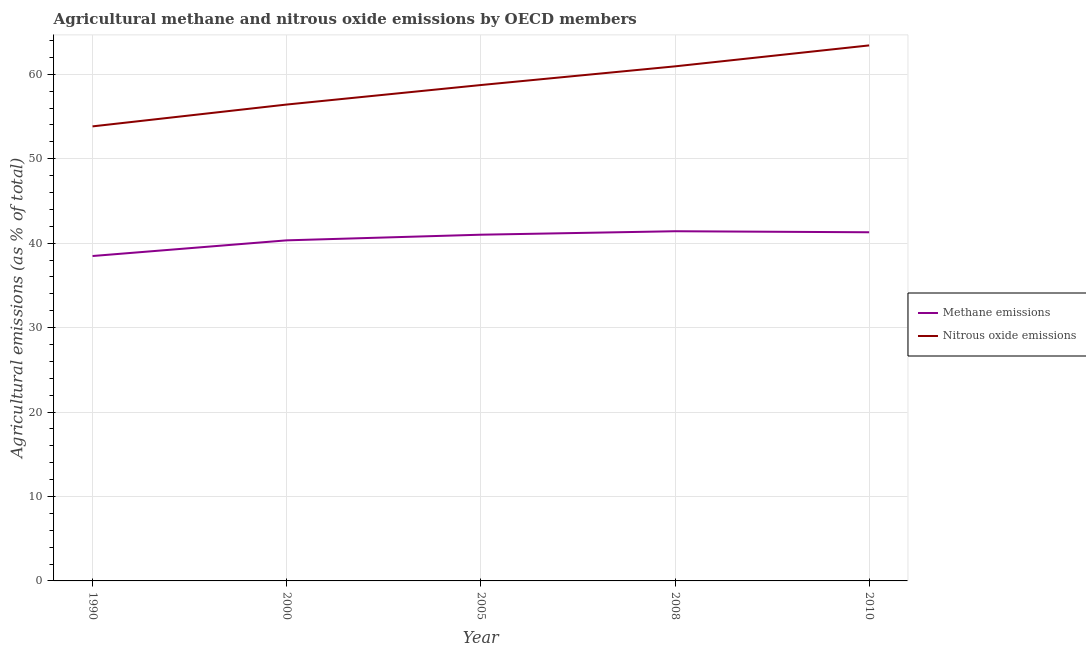How many different coloured lines are there?
Your answer should be compact. 2. Does the line corresponding to amount of nitrous oxide emissions intersect with the line corresponding to amount of methane emissions?
Provide a succinct answer. No. Is the number of lines equal to the number of legend labels?
Provide a short and direct response. Yes. What is the amount of methane emissions in 2010?
Offer a very short reply. 41.29. Across all years, what is the maximum amount of nitrous oxide emissions?
Your response must be concise. 63.42. Across all years, what is the minimum amount of methane emissions?
Your answer should be very brief. 38.48. In which year was the amount of methane emissions maximum?
Give a very brief answer. 2008. What is the total amount of methane emissions in the graph?
Offer a very short reply. 202.52. What is the difference between the amount of nitrous oxide emissions in 2000 and that in 2010?
Your answer should be compact. -7. What is the difference between the amount of methane emissions in 2005 and the amount of nitrous oxide emissions in 2010?
Offer a terse response. -22.42. What is the average amount of nitrous oxide emissions per year?
Make the answer very short. 58.67. In the year 2005, what is the difference between the amount of methane emissions and amount of nitrous oxide emissions?
Ensure brevity in your answer.  -17.72. In how many years, is the amount of nitrous oxide emissions greater than 44 %?
Offer a very short reply. 5. What is the ratio of the amount of nitrous oxide emissions in 1990 to that in 2008?
Offer a terse response. 0.88. Is the amount of methane emissions in 2000 less than that in 2010?
Your answer should be compact. Yes. What is the difference between the highest and the second highest amount of nitrous oxide emissions?
Ensure brevity in your answer.  2.48. What is the difference between the highest and the lowest amount of methane emissions?
Make the answer very short. 2.93. In how many years, is the amount of nitrous oxide emissions greater than the average amount of nitrous oxide emissions taken over all years?
Make the answer very short. 3. Is the sum of the amount of methane emissions in 2008 and 2010 greater than the maximum amount of nitrous oxide emissions across all years?
Your answer should be very brief. Yes. How many lines are there?
Ensure brevity in your answer.  2. How many years are there in the graph?
Make the answer very short. 5. Are the values on the major ticks of Y-axis written in scientific E-notation?
Your answer should be very brief. No. Does the graph contain any zero values?
Give a very brief answer. No. Does the graph contain grids?
Provide a short and direct response. Yes. Where does the legend appear in the graph?
Provide a succinct answer. Center right. How many legend labels are there?
Give a very brief answer. 2. What is the title of the graph?
Your answer should be very brief. Agricultural methane and nitrous oxide emissions by OECD members. Does "2012 US$" appear as one of the legend labels in the graph?
Ensure brevity in your answer.  No. What is the label or title of the Y-axis?
Your answer should be compact. Agricultural emissions (as % of total). What is the Agricultural emissions (as % of total) in Methane emissions in 1990?
Your response must be concise. 38.48. What is the Agricultural emissions (as % of total) in Nitrous oxide emissions in 1990?
Offer a terse response. 53.83. What is the Agricultural emissions (as % of total) in Methane emissions in 2000?
Provide a short and direct response. 40.33. What is the Agricultural emissions (as % of total) of Nitrous oxide emissions in 2000?
Make the answer very short. 56.42. What is the Agricultural emissions (as % of total) in Methane emissions in 2005?
Your response must be concise. 41. What is the Agricultural emissions (as % of total) of Nitrous oxide emissions in 2005?
Offer a terse response. 58.73. What is the Agricultural emissions (as % of total) in Methane emissions in 2008?
Keep it short and to the point. 41.41. What is the Agricultural emissions (as % of total) of Nitrous oxide emissions in 2008?
Offer a very short reply. 60.94. What is the Agricultural emissions (as % of total) of Methane emissions in 2010?
Provide a short and direct response. 41.29. What is the Agricultural emissions (as % of total) in Nitrous oxide emissions in 2010?
Give a very brief answer. 63.42. Across all years, what is the maximum Agricultural emissions (as % of total) of Methane emissions?
Keep it short and to the point. 41.41. Across all years, what is the maximum Agricultural emissions (as % of total) in Nitrous oxide emissions?
Give a very brief answer. 63.42. Across all years, what is the minimum Agricultural emissions (as % of total) of Methane emissions?
Your response must be concise. 38.48. Across all years, what is the minimum Agricultural emissions (as % of total) in Nitrous oxide emissions?
Ensure brevity in your answer.  53.83. What is the total Agricultural emissions (as % of total) in Methane emissions in the graph?
Provide a succinct answer. 202.52. What is the total Agricultural emissions (as % of total) of Nitrous oxide emissions in the graph?
Offer a very short reply. 293.34. What is the difference between the Agricultural emissions (as % of total) in Methane emissions in 1990 and that in 2000?
Your response must be concise. -1.86. What is the difference between the Agricultural emissions (as % of total) of Nitrous oxide emissions in 1990 and that in 2000?
Ensure brevity in your answer.  -2.59. What is the difference between the Agricultural emissions (as % of total) in Methane emissions in 1990 and that in 2005?
Your response must be concise. -2.52. What is the difference between the Agricultural emissions (as % of total) in Nitrous oxide emissions in 1990 and that in 2005?
Your answer should be very brief. -4.9. What is the difference between the Agricultural emissions (as % of total) in Methane emissions in 1990 and that in 2008?
Your response must be concise. -2.93. What is the difference between the Agricultural emissions (as % of total) in Nitrous oxide emissions in 1990 and that in 2008?
Keep it short and to the point. -7.11. What is the difference between the Agricultural emissions (as % of total) of Methane emissions in 1990 and that in 2010?
Provide a succinct answer. -2.81. What is the difference between the Agricultural emissions (as % of total) in Nitrous oxide emissions in 1990 and that in 2010?
Make the answer very short. -9.59. What is the difference between the Agricultural emissions (as % of total) of Methane emissions in 2000 and that in 2005?
Make the answer very short. -0.67. What is the difference between the Agricultural emissions (as % of total) in Nitrous oxide emissions in 2000 and that in 2005?
Offer a very short reply. -2.31. What is the difference between the Agricultural emissions (as % of total) of Methane emissions in 2000 and that in 2008?
Make the answer very short. -1.08. What is the difference between the Agricultural emissions (as % of total) in Nitrous oxide emissions in 2000 and that in 2008?
Your answer should be very brief. -4.52. What is the difference between the Agricultural emissions (as % of total) in Methane emissions in 2000 and that in 2010?
Give a very brief answer. -0.96. What is the difference between the Agricultural emissions (as % of total) in Nitrous oxide emissions in 2000 and that in 2010?
Make the answer very short. -7. What is the difference between the Agricultural emissions (as % of total) in Methane emissions in 2005 and that in 2008?
Provide a succinct answer. -0.41. What is the difference between the Agricultural emissions (as % of total) of Nitrous oxide emissions in 2005 and that in 2008?
Your answer should be very brief. -2.21. What is the difference between the Agricultural emissions (as % of total) in Methane emissions in 2005 and that in 2010?
Make the answer very short. -0.29. What is the difference between the Agricultural emissions (as % of total) of Nitrous oxide emissions in 2005 and that in 2010?
Offer a terse response. -4.69. What is the difference between the Agricultural emissions (as % of total) in Methane emissions in 2008 and that in 2010?
Ensure brevity in your answer.  0.12. What is the difference between the Agricultural emissions (as % of total) of Nitrous oxide emissions in 2008 and that in 2010?
Offer a terse response. -2.48. What is the difference between the Agricultural emissions (as % of total) of Methane emissions in 1990 and the Agricultural emissions (as % of total) of Nitrous oxide emissions in 2000?
Give a very brief answer. -17.94. What is the difference between the Agricultural emissions (as % of total) of Methane emissions in 1990 and the Agricultural emissions (as % of total) of Nitrous oxide emissions in 2005?
Keep it short and to the point. -20.25. What is the difference between the Agricultural emissions (as % of total) in Methane emissions in 1990 and the Agricultural emissions (as % of total) in Nitrous oxide emissions in 2008?
Make the answer very short. -22.46. What is the difference between the Agricultural emissions (as % of total) of Methane emissions in 1990 and the Agricultural emissions (as % of total) of Nitrous oxide emissions in 2010?
Offer a terse response. -24.94. What is the difference between the Agricultural emissions (as % of total) in Methane emissions in 2000 and the Agricultural emissions (as % of total) in Nitrous oxide emissions in 2005?
Your answer should be compact. -18.39. What is the difference between the Agricultural emissions (as % of total) of Methane emissions in 2000 and the Agricultural emissions (as % of total) of Nitrous oxide emissions in 2008?
Give a very brief answer. -20.61. What is the difference between the Agricultural emissions (as % of total) in Methane emissions in 2000 and the Agricultural emissions (as % of total) in Nitrous oxide emissions in 2010?
Provide a short and direct response. -23.09. What is the difference between the Agricultural emissions (as % of total) in Methane emissions in 2005 and the Agricultural emissions (as % of total) in Nitrous oxide emissions in 2008?
Offer a very short reply. -19.94. What is the difference between the Agricultural emissions (as % of total) in Methane emissions in 2005 and the Agricultural emissions (as % of total) in Nitrous oxide emissions in 2010?
Make the answer very short. -22.42. What is the difference between the Agricultural emissions (as % of total) of Methane emissions in 2008 and the Agricultural emissions (as % of total) of Nitrous oxide emissions in 2010?
Your answer should be very brief. -22.01. What is the average Agricultural emissions (as % of total) of Methane emissions per year?
Provide a short and direct response. 40.5. What is the average Agricultural emissions (as % of total) in Nitrous oxide emissions per year?
Your response must be concise. 58.67. In the year 1990, what is the difference between the Agricultural emissions (as % of total) in Methane emissions and Agricultural emissions (as % of total) in Nitrous oxide emissions?
Your answer should be compact. -15.35. In the year 2000, what is the difference between the Agricultural emissions (as % of total) in Methane emissions and Agricultural emissions (as % of total) in Nitrous oxide emissions?
Your answer should be very brief. -16.08. In the year 2005, what is the difference between the Agricultural emissions (as % of total) in Methane emissions and Agricultural emissions (as % of total) in Nitrous oxide emissions?
Offer a very short reply. -17.72. In the year 2008, what is the difference between the Agricultural emissions (as % of total) of Methane emissions and Agricultural emissions (as % of total) of Nitrous oxide emissions?
Your answer should be compact. -19.53. In the year 2010, what is the difference between the Agricultural emissions (as % of total) in Methane emissions and Agricultural emissions (as % of total) in Nitrous oxide emissions?
Keep it short and to the point. -22.13. What is the ratio of the Agricultural emissions (as % of total) of Methane emissions in 1990 to that in 2000?
Provide a short and direct response. 0.95. What is the ratio of the Agricultural emissions (as % of total) in Nitrous oxide emissions in 1990 to that in 2000?
Keep it short and to the point. 0.95. What is the ratio of the Agricultural emissions (as % of total) in Methane emissions in 1990 to that in 2005?
Your answer should be very brief. 0.94. What is the ratio of the Agricultural emissions (as % of total) in Nitrous oxide emissions in 1990 to that in 2005?
Your answer should be compact. 0.92. What is the ratio of the Agricultural emissions (as % of total) of Methane emissions in 1990 to that in 2008?
Give a very brief answer. 0.93. What is the ratio of the Agricultural emissions (as % of total) in Nitrous oxide emissions in 1990 to that in 2008?
Your response must be concise. 0.88. What is the ratio of the Agricultural emissions (as % of total) in Methane emissions in 1990 to that in 2010?
Offer a very short reply. 0.93. What is the ratio of the Agricultural emissions (as % of total) in Nitrous oxide emissions in 1990 to that in 2010?
Keep it short and to the point. 0.85. What is the ratio of the Agricultural emissions (as % of total) of Methane emissions in 2000 to that in 2005?
Your answer should be very brief. 0.98. What is the ratio of the Agricultural emissions (as % of total) in Nitrous oxide emissions in 2000 to that in 2005?
Provide a short and direct response. 0.96. What is the ratio of the Agricultural emissions (as % of total) in Nitrous oxide emissions in 2000 to that in 2008?
Make the answer very short. 0.93. What is the ratio of the Agricultural emissions (as % of total) in Methane emissions in 2000 to that in 2010?
Your response must be concise. 0.98. What is the ratio of the Agricultural emissions (as % of total) in Nitrous oxide emissions in 2000 to that in 2010?
Provide a short and direct response. 0.89. What is the ratio of the Agricultural emissions (as % of total) of Nitrous oxide emissions in 2005 to that in 2008?
Provide a short and direct response. 0.96. What is the ratio of the Agricultural emissions (as % of total) of Methane emissions in 2005 to that in 2010?
Ensure brevity in your answer.  0.99. What is the ratio of the Agricultural emissions (as % of total) of Nitrous oxide emissions in 2005 to that in 2010?
Offer a very short reply. 0.93. What is the ratio of the Agricultural emissions (as % of total) in Nitrous oxide emissions in 2008 to that in 2010?
Provide a succinct answer. 0.96. What is the difference between the highest and the second highest Agricultural emissions (as % of total) in Methane emissions?
Ensure brevity in your answer.  0.12. What is the difference between the highest and the second highest Agricultural emissions (as % of total) of Nitrous oxide emissions?
Keep it short and to the point. 2.48. What is the difference between the highest and the lowest Agricultural emissions (as % of total) in Methane emissions?
Ensure brevity in your answer.  2.93. What is the difference between the highest and the lowest Agricultural emissions (as % of total) of Nitrous oxide emissions?
Your answer should be compact. 9.59. 